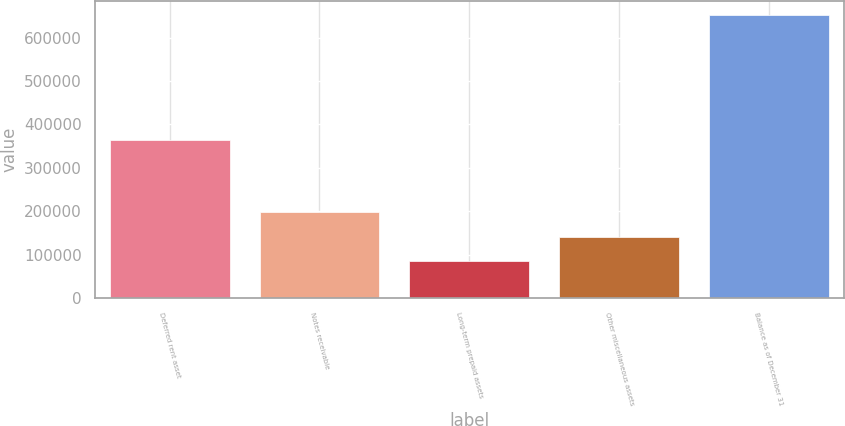Convert chart to OTSL. <chart><loc_0><loc_0><loc_500><loc_500><bar_chart><fcel>Deferred rent asset<fcel>Notes receivable<fcel>Long-term prepaid assets<fcel>Other miscellaneous assets<fcel>Balance as of December 31<nl><fcel>365112<fcel>198214<fcel>84801<fcel>141507<fcel>651864<nl></chart> 